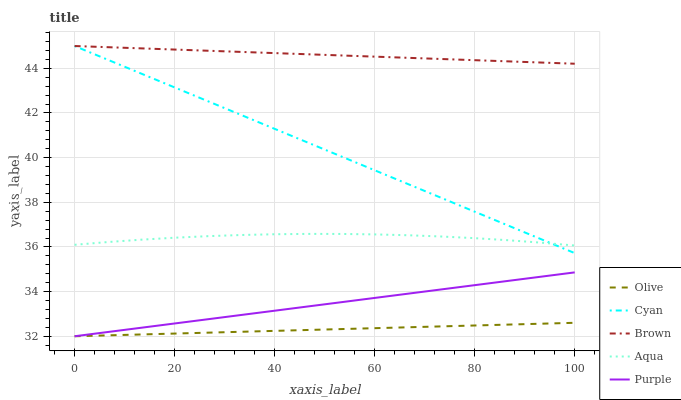Does Olive have the minimum area under the curve?
Answer yes or no. Yes. Does Brown have the maximum area under the curve?
Answer yes or no. Yes. Does Cyan have the minimum area under the curve?
Answer yes or no. No. Does Cyan have the maximum area under the curve?
Answer yes or no. No. Is Brown the smoothest?
Answer yes or no. Yes. Is Aqua the roughest?
Answer yes or no. Yes. Is Cyan the smoothest?
Answer yes or no. No. Is Cyan the roughest?
Answer yes or no. No. Does Olive have the lowest value?
Answer yes or no. Yes. Does Cyan have the lowest value?
Answer yes or no. No. Does Brown have the highest value?
Answer yes or no. Yes. Does Aqua have the highest value?
Answer yes or no. No. Is Purple less than Brown?
Answer yes or no. Yes. Is Cyan greater than Olive?
Answer yes or no. Yes. Does Cyan intersect Brown?
Answer yes or no. Yes. Is Cyan less than Brown?
Answer yes or no. No. Is Cyan greater than Brown?
Answer yes or no. No. Does Purple intersect Brown?
Answer yes or no. No. 